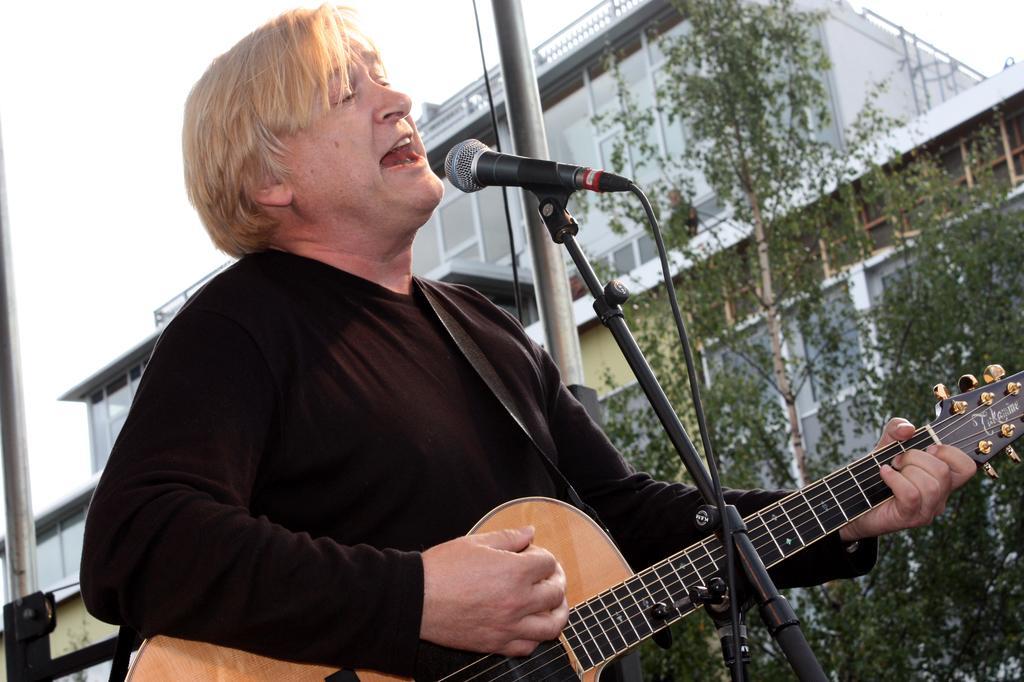Could you give a brief overview of what you see in this image? In the center we can see two persons were standing and holding guitar and he is singing. In front there is a microphone. In the background we can see sky with clouds,building and trees. 